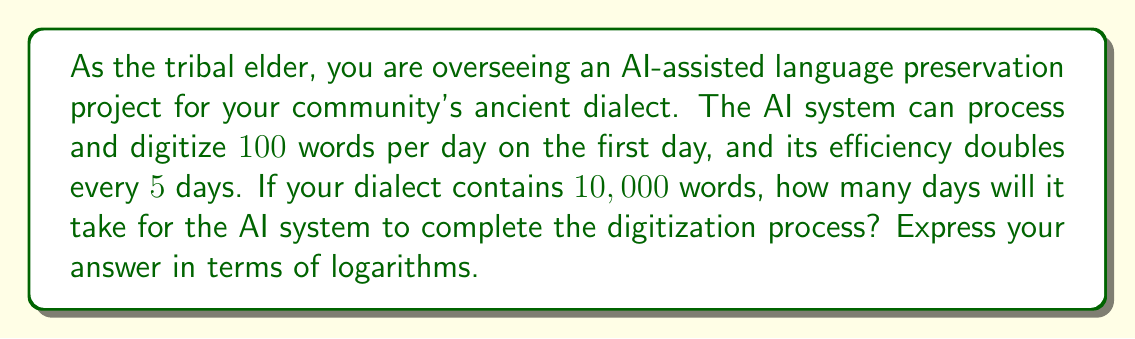Give your solution to this math problem. Let's approach this step-by-step:

1) First, let's define our variables:
   $t$ = number of days
   $w(t)$ = number of words processed by day $t$

2) We know that the AI's efficiency doubles every 5 days. We can express this as:
   $$w(t) = 100 \cdot 2^{\frac{t}{5}}$$

3) We need to find when the total number of words processed equals 10,000. We can express this as an equation:
   $$\int_0^t w(t) dt = 10000$$

4) Substituting our function:
   $$\int_0^t 100 \cdot 2^{\frac{t}{5}} dt = 10000$$

5) Solving the integral:
   $$\left[100 \cdot 2^{\frac{t}{5}} \cdot \frac{5}{\ln(2)}\right]_0^t = 10000$$

6) Evaluating the integral:
   $$100 \cdot 2^{\frac{t}{5}} \cdot \frac{5}{\ln(2)} - 100 \cdot 2^0 \cdot \frac{5}{\ln(2)} = 10000$$

7) Simplifying:
   $$100 \cdot 2^{\frac{t}{5}} \cdot \frac{5}{\ln(2)} - \frac{500}{\ln(2)} = 10000$$

8) Solving for $2^{\frac{t}{5}}$:
   $$2^{\frac{t}{5}} = \frac{10000\ln(2) + 500}{500}$$

9) Taking the logarithm of both sides:
   $$\frac{t}{5} = \log_2\left(\frac{10000\ln(2) + 500}{500}\right)$$

10) Solving for $t$:
    $$t = 5 \log_2\left(\frac{10000\ln(2) + 500}{500}\right)$$

This is our final answer in terms of logarithms.
Answer: $t = 5 \log_2\left(\frac{10000\ln(2) + 500}{500}\right)$ days 